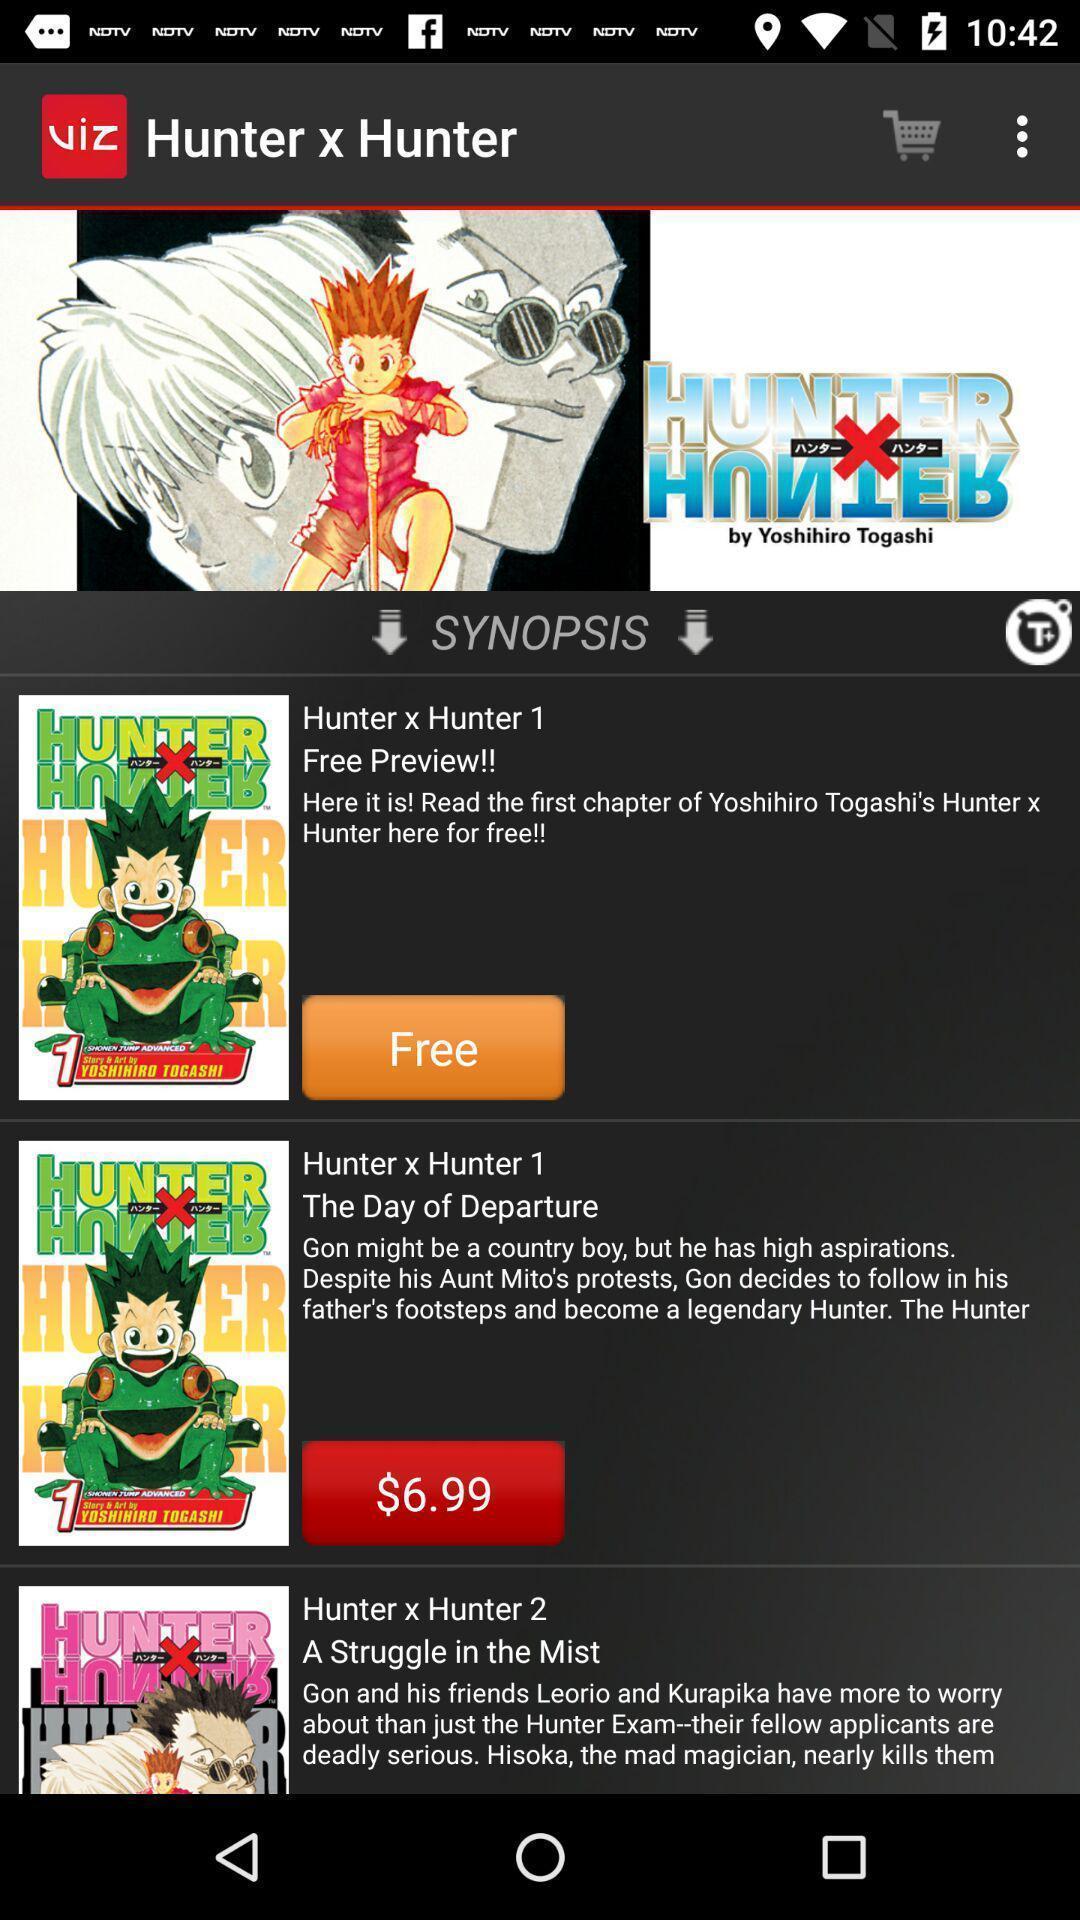Explain the elements present in this screenshot. Screen shows about a synopsis. 